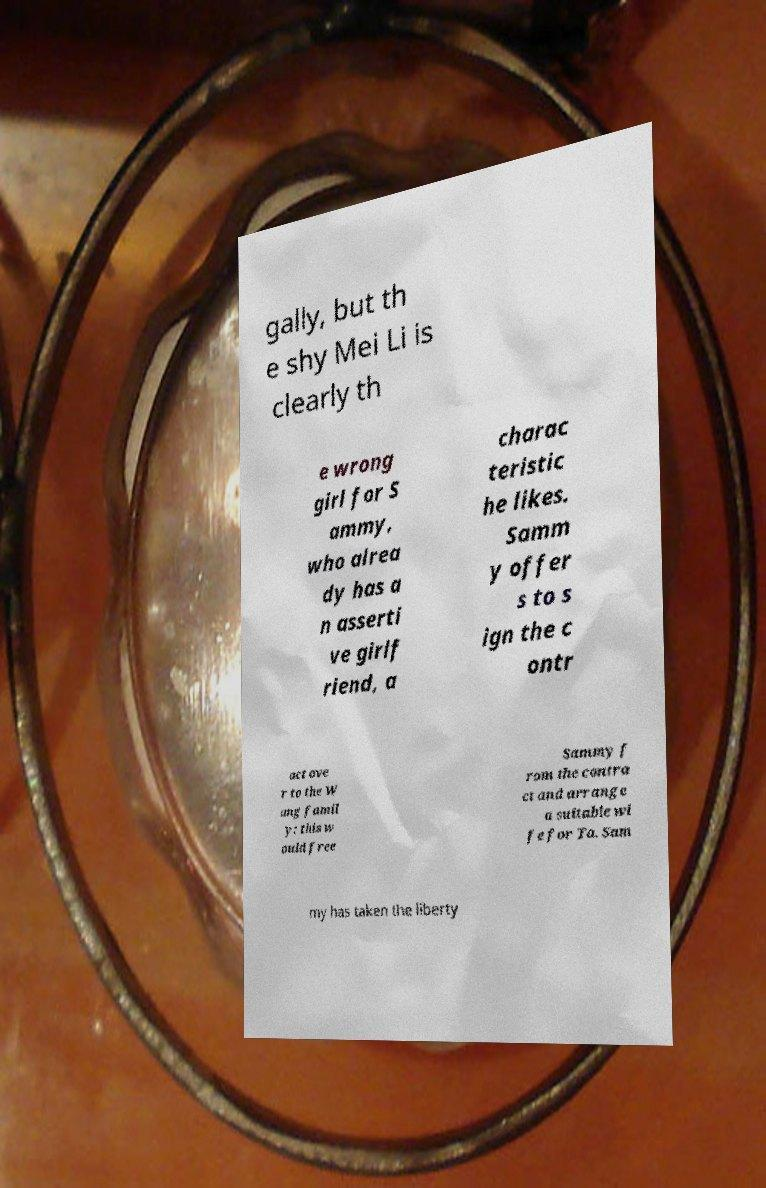Please read and relay the text visible in this image. What does it say? gally, but th e shy Mei Li is clearly th e wrong girl for S ammy, who alrea dy has a n asserti ve girlf riend, a charac teristic he likes. Samm y offer s to s ign the c ontr act ove r to the W ang famil y: this w ould free Sammy f rom the contra ct and arrange a suitable wi fe for Ta. Sam my has taken the liberty 